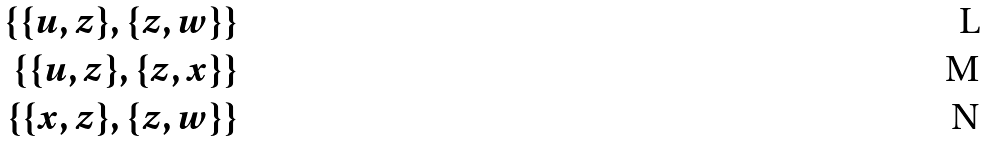Convert formula to latex. <formula><loc_0><loc_0><loc_500><loc_500>\{ \{ u , z \} , \{ z , w \} \} \\ \{ \{ u , z \} , \{ z , x \} \} \\ \{ \{ x , z \} , \{ z , w \} \}</formula> 